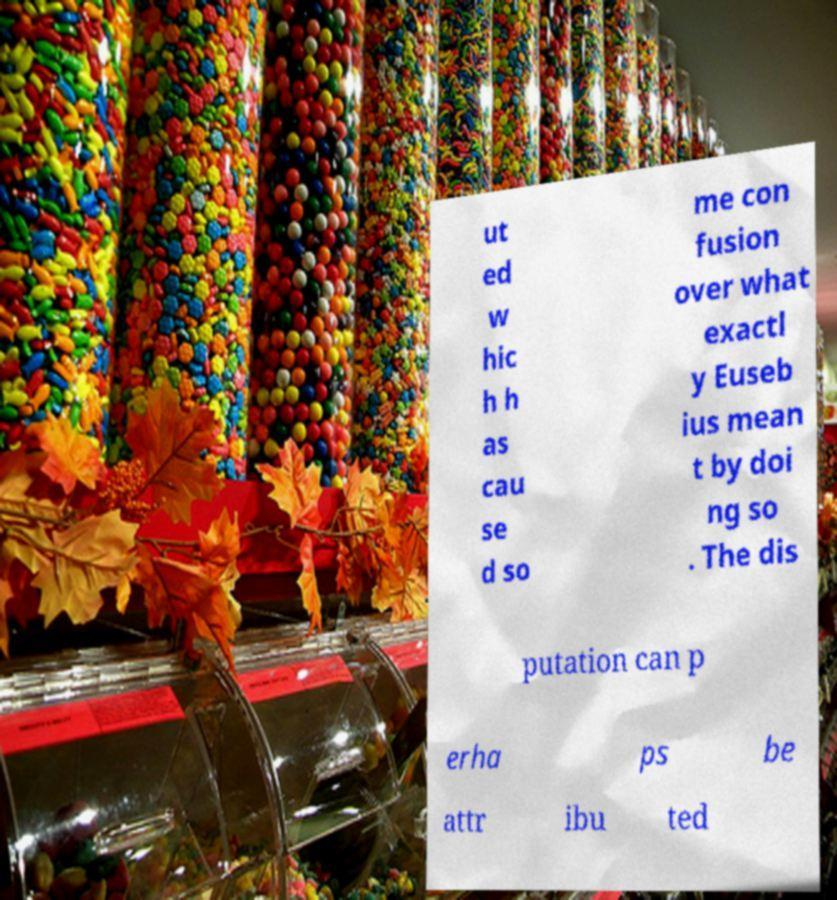Please identify and transcribe the text found in this image. ut ed w hic h h as cau se d so me con fusion over what exactl y Euseb ius mean t by doi ng so . The dis putation can p erha ps be attr ibu ted 